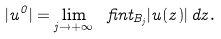<formula> <loc_0><loc_0><loc_500><loc_500>| u ^ { 0 } | = \lim _ { j \to + \infty } \ f i n t _ { B _ { j } } | u ( z ) | \, d z .</formula> 